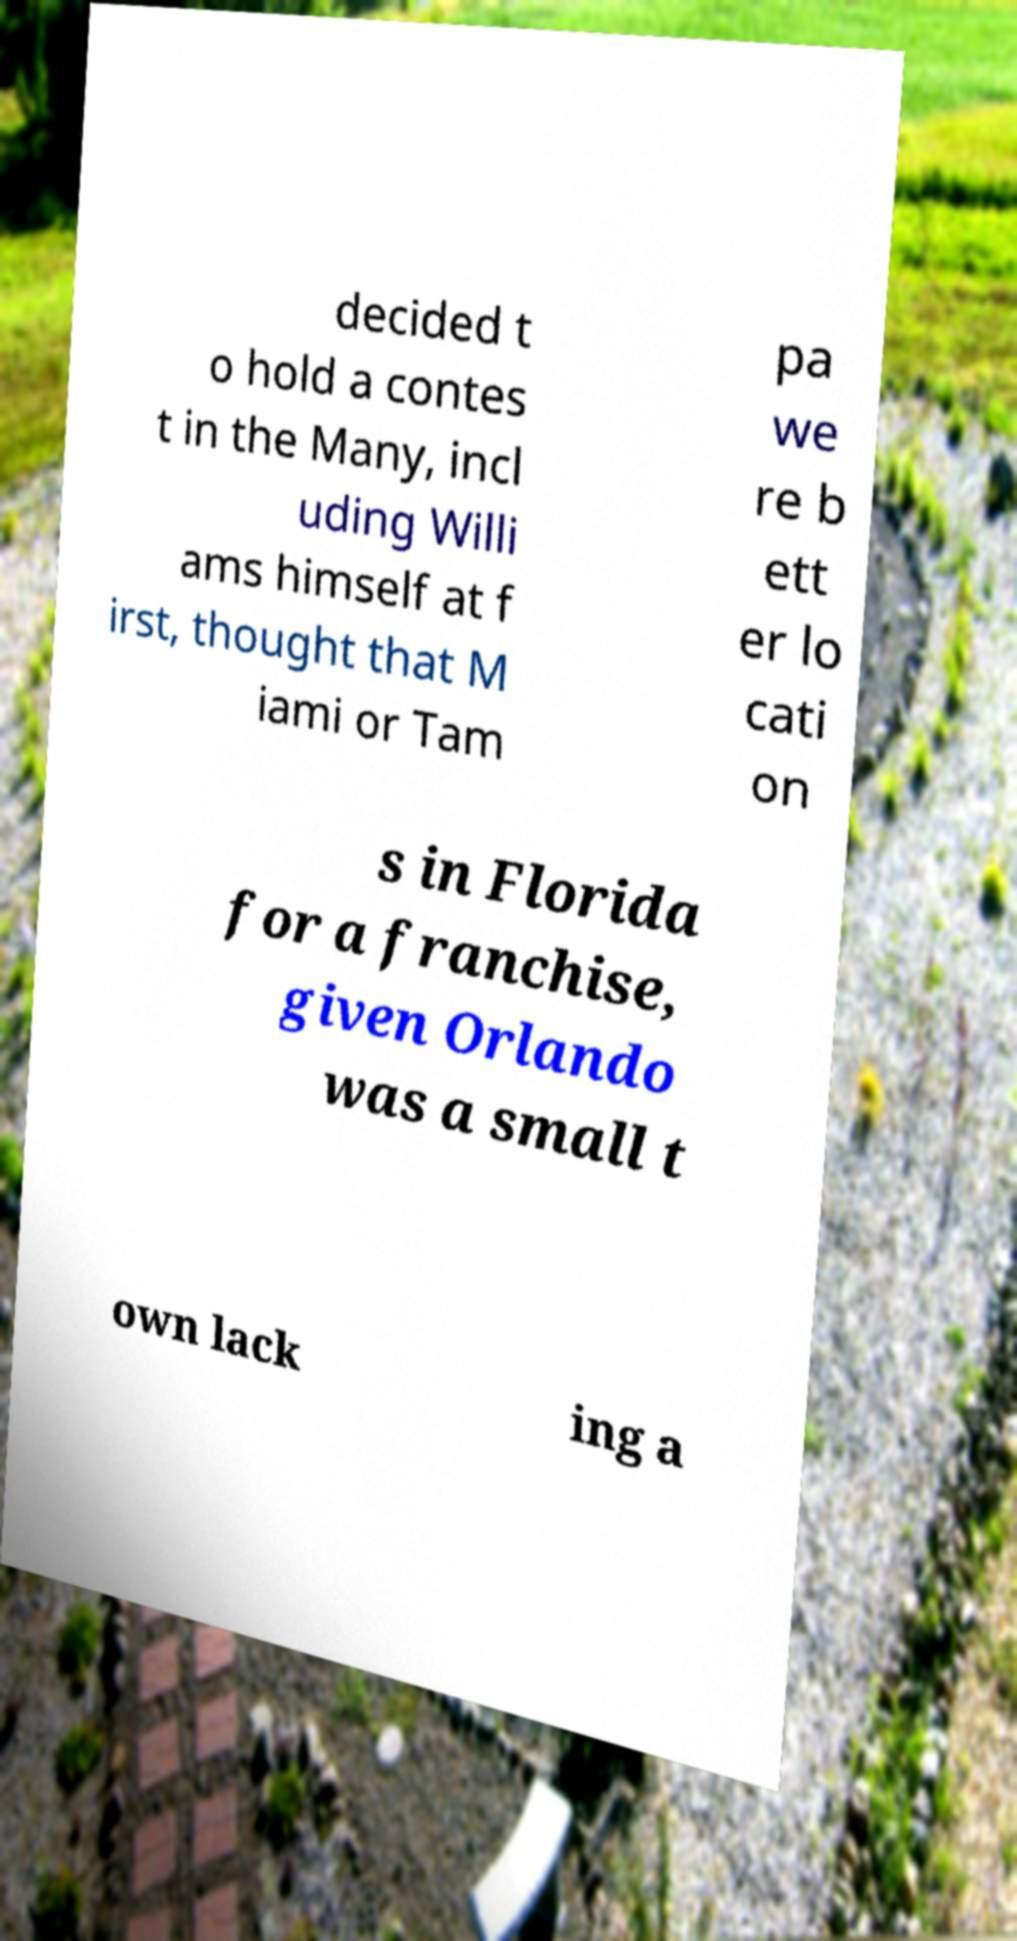Please read and relay the text visible in this image. What does it say? decided t o hold a contes t in the Many, incl uding Willi ams himself at f irst, thought that M iami or Tam pa we re b ett er lo cati on s in Florida for a franchise, given Orlando was a small t own lack ing a 